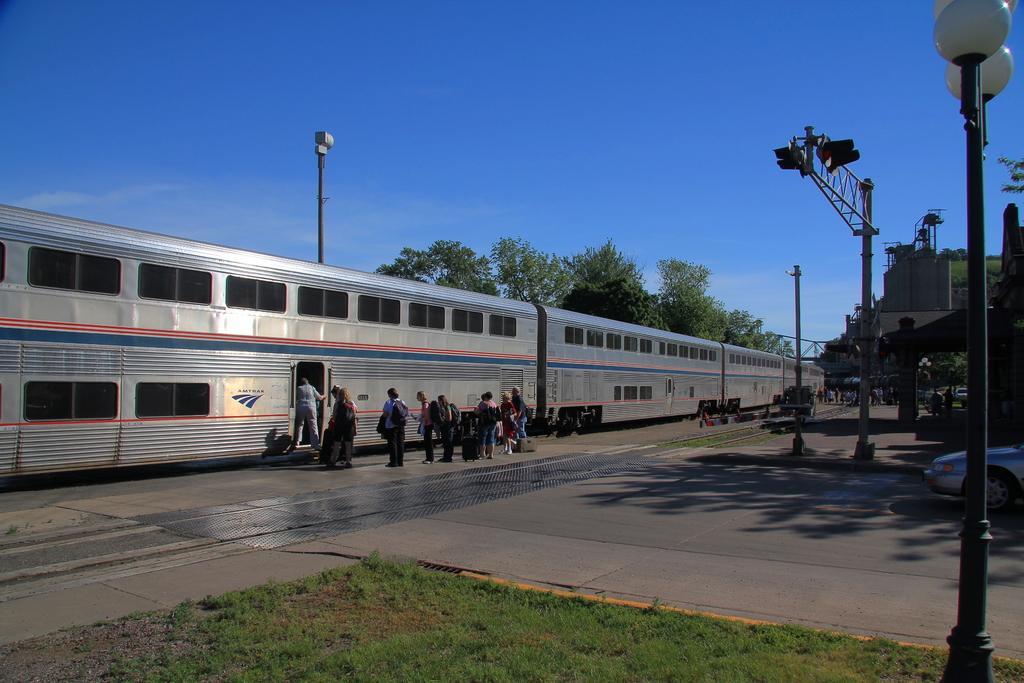Describe this image in one or two sentences. In this picture I can see there is a train and there are few people boarding the train, there is a vehicle on the right side, there is some grass on the floor. There are few trees at left side, buildings to the right and the sky is clear. 